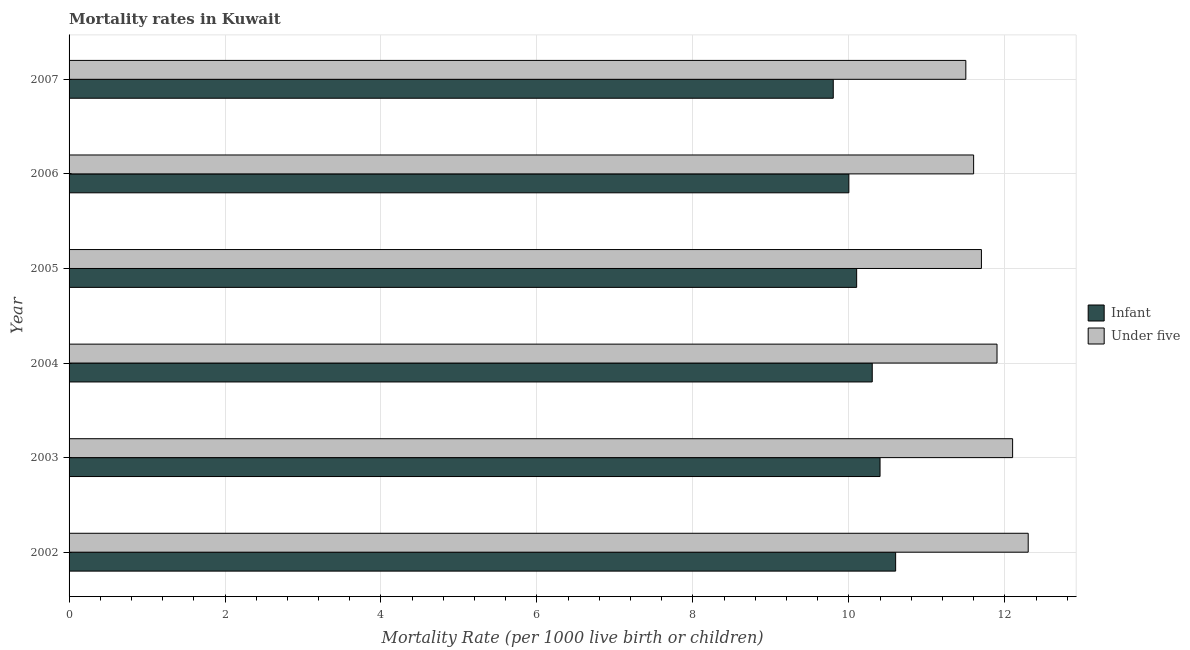How many groups of bars are there?
Ensure brevity in your answer.  6. How many bars are there on the 3rd tick from the bottom?
Your answer should be compact. 2. What is the label of the 1st group of bars from the top?
Your answer should be compact. 2007. In how many cases, is the number of bars for a given year not equal to the number of legend labels?
Make the answer very short. 0. What is the infant mortality rate in 2002?
Your answer should be compact. 10.6. Across all years, what is the maximum under-5 mortality rate?
Keep it short and to the point. 12.3. What is the total under-5 mortality rate in the graph?
Make the answer very short. 71.1. What is the difference between the under-5 mortality rate in 2004 and that in 2005?
Offer a very short reply. 0.2. What is the difference between the under-5 mortality rate in 2007 and the infant mortality rate in 2003?
Provide a short and direct response. 1.1. In the year 2006, what is the difference between the under-5 mortality rate and infant mortality rate?
Your response must be concise. 1.6. In how many years, is the under-5 mortality rate greater than 5.6 ?
Your answer should be very brief. 6. What is the ratio of the under-5 mortality rate in 2002 to that in 2004?
Your response must be concise. 1.03. Is the under-5 mortality rate in 2003 less than that in 2005?
Make the answer very short. No. Is the difference between the infant mortality rate in 2002 and 2004 greater than the difference between the under-5 mortality rate in 2002 and 2004?
Make the answer very short. No. What does the 1st bar from the top in 2003 represents?
Keep it short and to the point. Under five. What does the 2nd bar from the bottom in 2002 represents?
Offer a terse response. Under five. Are all the bars in the graph horizontal?
Offer a very short reply. Yes. How many years are there in the graph?
Give a very brief answer. 6. What is the difference between two consecutive major ticks on the X-axis?
Your answer should be very brief. 2. Are the values on the major ticks of X-axis written in scientific E-notation?
Offer a very short reply. No. Does the graph contain any zero values?
Your answer should be compact. No. What is the title of the graph?
Make the answer very short. Mortality rates in Kuwait. Does "Public funds" appear as one of the legend labels in the graph?
Your answer should be very brief. No. What is the label or title of the X-axis?
Your response must be concise. Mortality Rate (per 1000 live birth or children). What is the label or title of the Y-axis?
Give a very brief answer. Year. What is the Mortality Rate (per 1000 live birth or children) in Under five in 2002?
Make the answer very short. 12.3. What is the Mortality Rate (per 1000 live birth or children) of Infant in 2004?
Give a very brief answer. 10.3. What is the Mortality Rate (per 1000 live birth or children) in Under five in 2006?
Offer a very short reply. 11.6. What is the Mortality Rate (per 1000 live birth or children) in Under five in 2007?
Offer a very short reply. 11.5. Across all years, what is the maximum Mortality Rate (per 1000 live birth or children) in Infant?
Offer a terse response. 10.6. Across all years, what is the minimum Mortality Rate (per 1000 live birth or children) in Infant?
Offer a terse response. 9.8. What is the total Mortality Rate (per 1000 live birth or children) in Infant in the graph?
Keep it short and to the point. 61.2. What is the total Mortality Rate (per 1000 live birth or children) in Under five in the graph?
Provide a short and direct response. 71.1. What is the difference between the Mortality Rate (per 1000 live birth or children) in Under five in 2002 and that in 2003?
Make the answer very short. 0.2. What is the difference between the Mortality Rate (per 1000 live birth or children) in Infant in 2002 and that in 2004?
Your answer should be compact. 0.3. What is the difference between the Mortality Rate (per 1000 live birth or children) in Infant in 2002 and that in 2006?
Give a very brief answer. 0.6. What is the difference between the Mortality Rate (per 1000 live birth or children) of Under five in 2002 and that in 2007?
Ensure brevity in your answer.  0.8. What is the difference between the Mortality Rate (per 1000 live birth or children) of Infant in 2003 and that in 2004?
Make the answer very short. 0.1. What is the difference between the Mortality Rate (per 1000 live birth or children) in Infant in 2003 and that in 2005?
Provide a short and direct response. 0.3. What is the difference between the Mortality Rate (per 1000 live birth or children) in Under five in 2003 and that in 2005?
Your answer should be compact. 0.4. What is the difference between the Mortality Rate (per 1000 live birth or children) in Infant in 2003 and that in 2006?
Make the answer very short. 0.4. What is the difference between the Mortality Rate (per 1000 live birth or children) of Under five in 2003 and that in 2007?
Offer a terse response. 0.6. What is the difference between the Mortality Rate (per 1000 live birth or children) of Infant in 2004 and that in 2005?
Provide a succinct answer. 0.2. What is the difference between the Mortality Rate (per 1000 live birth or children) of Under five in 2004 and that in 2005?
Give a very brief answer. 0.2. What is the difference between the Mortality Rate (per 1000 live birth or children) in Infant in 2004 and that in 2006?
Offer a very short reply. 0.3. What is the difference between the Mortality Rate (per 1000 live birth or children) of Under five in 2004 and that in 2007?
Keep it short and to the point. 0.4. What is the difference between the Mortality Rate (per 1000 live birth or children) of Under five in 2005 and that in 2007?
Your answer should be very brief. 0.2. What is the difference between the Mortality Rate (per 1000 live birth or children) of Under five in 2006 and that in 2007?
Offer a very short reply. 0.1. What is the difference between the Mortality Rate (per 1000 live birth or children) of Infant in 2002 and the Mortality Rate (per 1000 live birth or children) of Under five in 2004?
Make the answer very short. -1.3. What is the difference between the Mortality Rate (per 1000 live birth or children) in Infant in 2002 and the Mortality Rate (per 1000 live birth or children) in Under five in 2007?
Your answer should be compact. -0.9. What is the difference between the Mortality Rate (per 1000 live birth or children) in Infant in 2003 and the Mortality Rate (per 1000 live birth or children) in Under five in 2004?
Provide a short and direct response. -1.5. What is the difference between the Mortality Rate (per 1000 live birth or children) of Infant in 2003 and the Mortality Rate (per 1000 live birth or children) of Under five in 2007?
Your answer should be compact. -1.1. What is the difference between the Mortality Rate (per 1000 live birth or children) of Infant in 2004 and the Mortality Rate (per 1000 live birth or children) of Under five in 2006?
Keep it short and to the point. -1.3. What is the difference between the Mortality Rate (per 1000 live birth or children) in Infant in 2004 and the Mortality Rate (per 1000 live birth or children) in Under five in 2007?
Keep it short and to the point. -1.2. What is the difference between the Mortality Rate (per 1000 live birth or children) in Infant in 2005 and the Mortality Rate (per 1000 live birth or children) in Under five in 2006?
Ensure brevity in your answer.  -1.5. What is the difference between the Mortality Rate (per 1000 live birth or children) in Infant in 2006 and the Mortality Rate (per 1000 live birth or children) in Under five in 2007?
Ensure brevity in your answer.  -1.5. What is the average Mortality Rate (per 1000 live birth or children) in Under five per year?
Provide a succinct answer. 11.85. What is the ratio of the Mortality Rate (per 1000 live birth or children) of Infant in 2002 to that in 2003?
Offer a very short reply. 1.02. What is the ratio of the Mortality Rate (per 1000 live birth or children) of Under five in 2002 to that in 2003?
Your response must be concise. 1.02. What is the ratio of the Mortality Rate (per 1000 live birth or children) in Infant in 2002 to that in 2004?
Make the answer very short. 1.03. What is the ratio of the Mortality Rate (per 1000 live birth or children) of Under five in 2002 to that in 2004?
Your answer should be very brief. 1.03. What is the ratio of the Mortality Rate (per 1000 live birth or children) in Infant in 2002 to that in 2005?
Provide a succinct answer. 1.05. What is the ratio of the Mortality Rate (per 1000 live birth or children) in Under five in 2002 to that in 2005?
Keep it short and to the point. 1.05. What is the ratio of the Mortality Rate (per 1000 live birth or children) of Infant in 2002 to that in 2006?
Make the answer very short. 1.06. What is the ratio of the Mortality Rate (per 1000 live birth or children) in Under five in 2002 to that in 2006?
Your answer should be very brief. 1.06. What is the ratio of the Mortality Rate (per 1000 live birth or children) in Infant in 2002 to that in 2007?
Make the answer very short. 1.08. What is the ratio of the Mortality Rate (per 1000 live birth or children) in Under five in 2002 to that in 2007?
Your answer should be very brief. 1.07. What is the ratio of the Mortality Rate (per 1000 live birth or children) in Infant in 2003 to that in 2004?
Provide a succinct answer. 1.01. What is the ratio of the Mortality Rate (per 1000 live birth or children) of Under five in 2003 to that in 2004?
Make the answer very short. 1.02. What is the ratio of the Mortality Rate (per 1000 live birth or children) of Infant in 2003 to that in 2005?
Provide a short and direct response. 1.03. What is the ratio of the Mortality Rate (per 1000 live birth or children) of Under five in 2003 to that in 2005?
Ensure brevity in your answer.  1.03. What is the ratio of the Mortality Rate (per 1000 live birth or children) in Infant in 2003 to that in 2006?
Offer a terse response. 1.04. What is the ratio of the Mortality Rate (per 1000 live birth or children) in Under five in 2003 to that in 2006?
Provide a succinct answer. 1.04. What is the ratio of the Mortality Rate (per 1000 live birth or children) in Infant in 2003 to that in 2007?
Make the answer very short. 1.06. What is the ratio of the Mortality Rate (per 1000 live birth or children) of Under five in 2003 to that in 2007?
Your answer should be compact. 1.05. What is the ratio of the Mortality Rate (per 1000 live birth or children) of Infant in 2004 to that in 2005?
Provide a short and direct response. 1.02. What is the ratio of the Mortality Rate (per 1000 live birth or children) of Under five in 2004 to that in 2005?
Your answer should be very brief. 1.02. What is the ratio of the Mortality Rate (per 1000 live birth or children) in Infant in 2004 to that in 2006?
Ensure brevity in your answer.  1.03. What is the ratio of the Mortality Rate (per 1000 live birth or children) in Under five in 2004 to that in 2006?
Your answer should be compact. 1.03. What is the ratio of the Mortality Rate (per 1000 live birth or children) of Infant in 2004 to that in 2007?
Your answer should be compact. 1.05. What is the ratio of the Mortality Rate (per 1000 live birth or children) of Under five in 2004 to that in 2007?
Offer a terse response. 1.03. What is the ratio of the Mortality Rate (per 1000 live birth or children) in Under five in 2005 to that in 2006?
Keep it short and to the point. 1.01. What is the ratio of the Mortality Rate (per 1000 live birth or children) in Infant in 2005 to that in 2007?
Offer a terse response. 1.03. What is the ratio of the Mortality Rate (per 1000 live birth or children) of Under five in 2005 to that in 2007?
Your response must be concise. 1.02. What is the ratio of the Mortality Rate (per 1000 live birth or children) of Infant in 2006 to that in 2007?
Your answer should be very brief. 1.02. What is the ratio of the Mortality Rate (per 1000 live birth or children) of Under five in 2006 to that in 2007?
Ensure brevity in your answer.  1.01. What is the difference between the highest and the second highest Mortality Rate (per 1000 live birth or children) in Infant?
Give a very brief answer. 0.2. What is the difference between the highest and the lowest Mortality Rate (per 1000 live birth or children) in Infant?
Your answer should be compact. 0.8. 